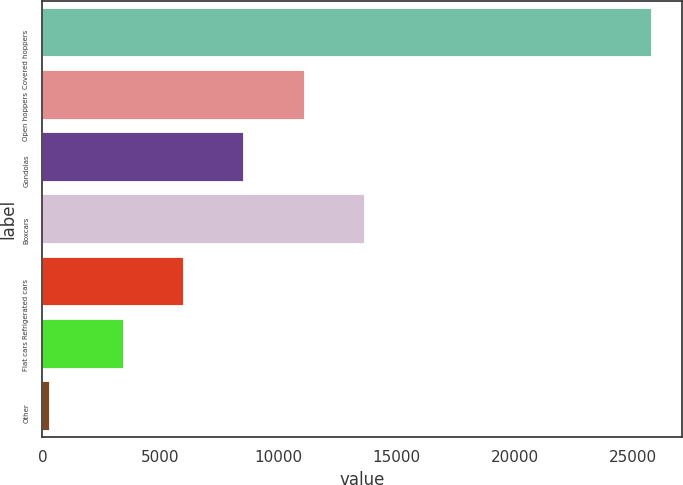Convert chart to OTSL. <chart><loc_0><loc_0><loc_500><loc_500><bar_chart><fcel>Covered hoppers<fcel>Open hoppers<fcel>Gondolas<fcel>Boxcars<fcel>Refrigerated cars<fcel>Flat cars<fcel>Other<nl><fcel>25785<fcel>11094.5<fcel>8550<fcel>13639<fcel>6005.5<fcel>3461<fcel>340<nl></chart> 